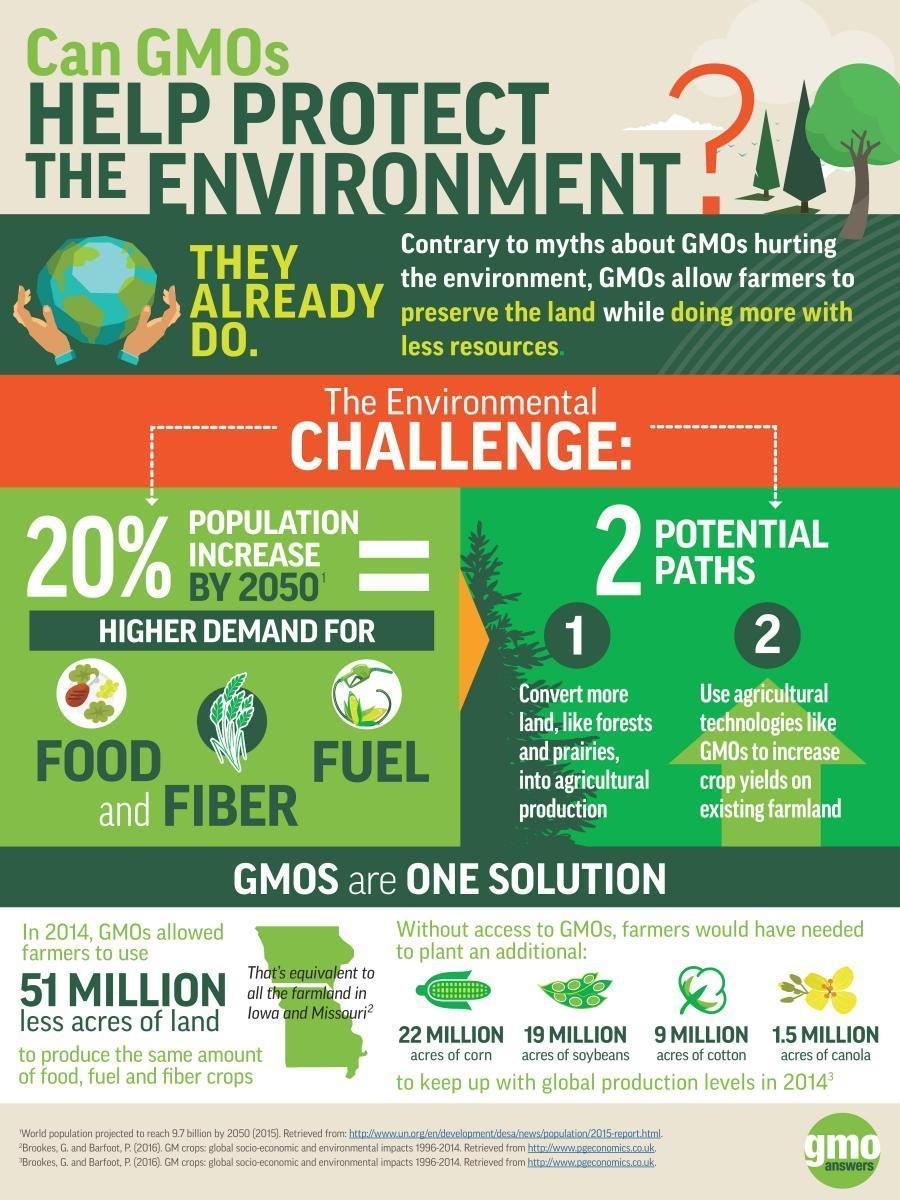If it wasn't for the GMOs, how many additional acres of corn would have been needed?
Answer the question with a short phrase. 22 million Which industries will face an "increased demand" due to an increase in population in 2050? Food, fiber, fuel Which fibre crop would have needed an additional 9 million acres, if it wasn't for the GMOs? Cotton What is the area of the total farmlands in Iowa and Mussoorie (acres)? 51 million What can forests and prairies be used for? Agricultural production Which are the 3 food crops, for which additional land would have been required, if it wasn't for the GMOs? Corn, soybeans, canola Which food crop would have needed an additional 22 million acres, if it wasn't for the GMOs? Corn What are the two ways in which GMOs help farmers? Preserve the land, doing more with less resources If it wasn't for the GMOs, how many additional acres of cotton would have been needed? 9 million 